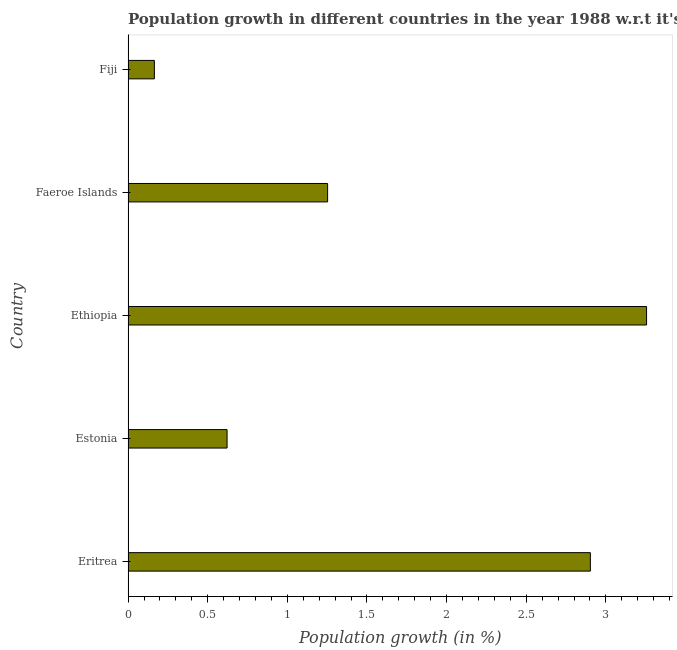Does the graph contain grids?
Offer a very short reply. No. What is the title of the graph?
Offer a very short reply. Population growth in different countries in the year 1988 w.r.t it's previous year. What is the label or title of the X-axis?
Give a very brief answer. Population growth (in %). What is the population growth in Ethiopia?
Make the answer very short. 3.26. Across all countries, what is the maximum population growth?
Offer a terse response. 3.26. Across all countries, what is the minimum population growth?
Offer a terse response. 0.17. In which country was the population growth maximum?
Provide a succinct answer. Ethiopia. In which country was the population growth minimum?
Ensure brevity in your answer.  Fiji. What is the sum of the population growth?
Your answer should be compact. 8.2. What is the difference between the population growth in Estonia and Ethiopia?
Make the answer very short. -2.63. What is the average population growth per country?
Your response must be concise. 1.64. What is the median population growth?
Make the answer very short. 1.25. In how many countries, is the population growth greater than 3.1 %?
Offer a very short reply. 1. What is the ratio of the population growth in Faeroe Islands to that in Fiji?
Your answer should be very brief. 7.59. Is the difference between the population growth in Ethiopia and Faeroe Islands greater than the difference between any two countries?
Your answer should be compact. No. What is the difference between the highest and the second highest population growth?
Make the answer very short. 0.35. What is the difference between the highest and the lowest population growth?
Offer a terse response. 3.09. In how many countries, is the population growth greater than the average population growth taken over all countries?
Provide a short and direct response. 2. How many bars are there?
Offer a terse response. 5. How many countries are there in the graph?
Give a very brief answer. 5. What is the difference between two consecutive major ticks on the X-axis?
Your answer should be very brief. 0.5. Are the values on the major ticks of X-axis written in scientific E-notation?
Make the answer very short. No. What is the Population growth (in %) in Eritrea?
Provide a short and direct response. 2.9. What is the Population growth (in %) in Estonia?
Your answer should be compact. 0.62. What is the Population growth (in %) in Ethiopia?
Keep it short and to the point. 3.26. What is the Population growth (in %) in Faeroe Islands?
Provide a succinct answer. 1.25. What is the Population growth (in %) in Fiji?
Ensure brevity in your answer.  0.17. What is the difference between the Population growth (in %) in Eritrea and Estonia?
Offer a very short reply. 2.28. What is the difference between the Population growth (in %) in Eritrea and Ethiopia?
Offer a terse response. -0.35. What is the difference between the Population growth (in %) in Eritrea and Faeroe Islands?
Your answer should be compact. 1.65. What is the difference between the Population growth (in %) in Eritrea and Fiji?
Provide a short and direct response. 2.74. What is the difference between the Population growth (in %) in Estonia and Ethiopia?
Offer a very short reply. -2.63. What is the difference between the Population growth (in %) in Estonia and Faeroe Islands?
Your answer should be compact. -0.63. What is the difference between the Population growth (in %) in Estonia and Fiji?
Keep it short and to the point. 0.46. What is the difference between the Population growth (in %) in Ethiopia and Faeroe Islands?
Make the answer very short. 2. What is the difference between the Population growth (in %) in Ethiopia and Fiji?
Your response must be concise. 3.09. What is the difference between the Population growth (in %) in Faeroe Islands and Fiji?
Your response must be concise. 1.09. What is the ratio of the Population growth (in %) in Eritrea to that in Estonia?
Your answer should be compact. 4.67. What is the ratio of the Population growth (in %) in Eritrea to that in Ethiopia?
Make the answer very short. 0.89. What is the ratio of the Population growth (in %) in Eritrea to that in Faeroe Islands?
Your answer should be compact. 2.32. What is the ratio of the Population growth (in %) in Eritrea to that in Fiji?
Make the answer very short. 17.57. What is the ratio of the Population growth (in %) in Estonia to that in Ethiopia?
Your answer should be very brief. 0.19. What is the ratio of the Population growth (in %) in Estonia to that in Faeroe Islands?
Your answer should be very brief. 0.5. What is the ratio of the Population growth (in %) in Estonia to that in Fiji?
Your answer should be compact. 3.76. What is the ratio of the Population growth (in %) in Ethiopia to that in Faeroe Islands?
Offer a terse response. 2.6. What is the ratio of the Population growth (in %) in Ethiopia to that in Fiji?
Your answer should be very brief. 19.71. What is the ratio of the Population growth (in %) in Faeroe Islands to that in Fiji?
Your response must be concise. 7.59. 